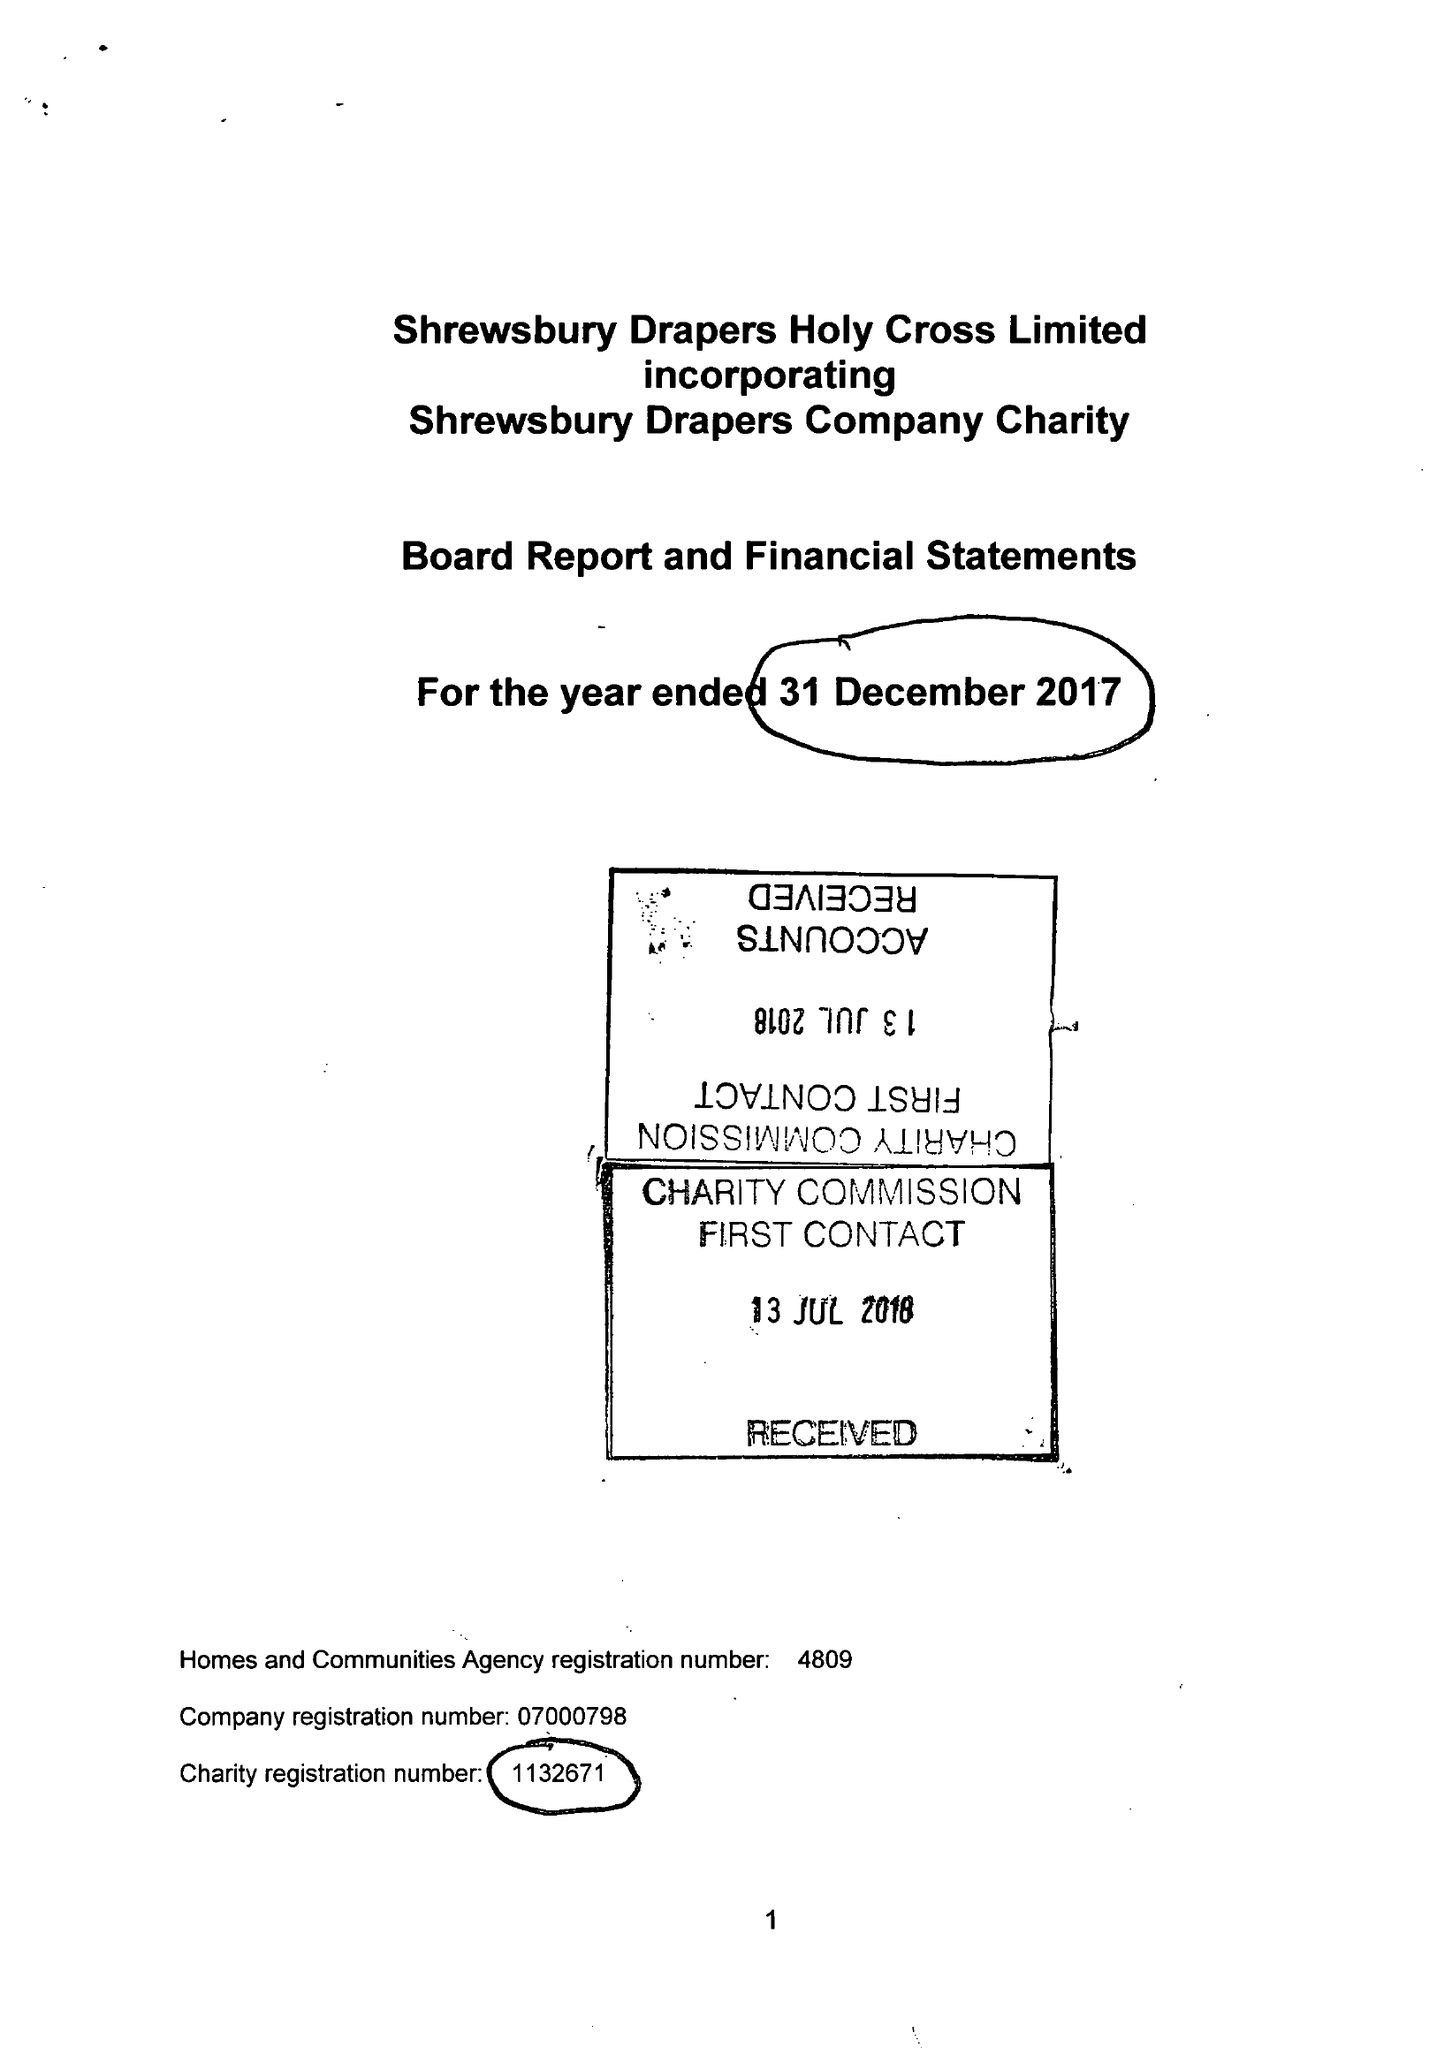What is the value for the charity_number?
Answer the question using a single word or phrase. 1132671 